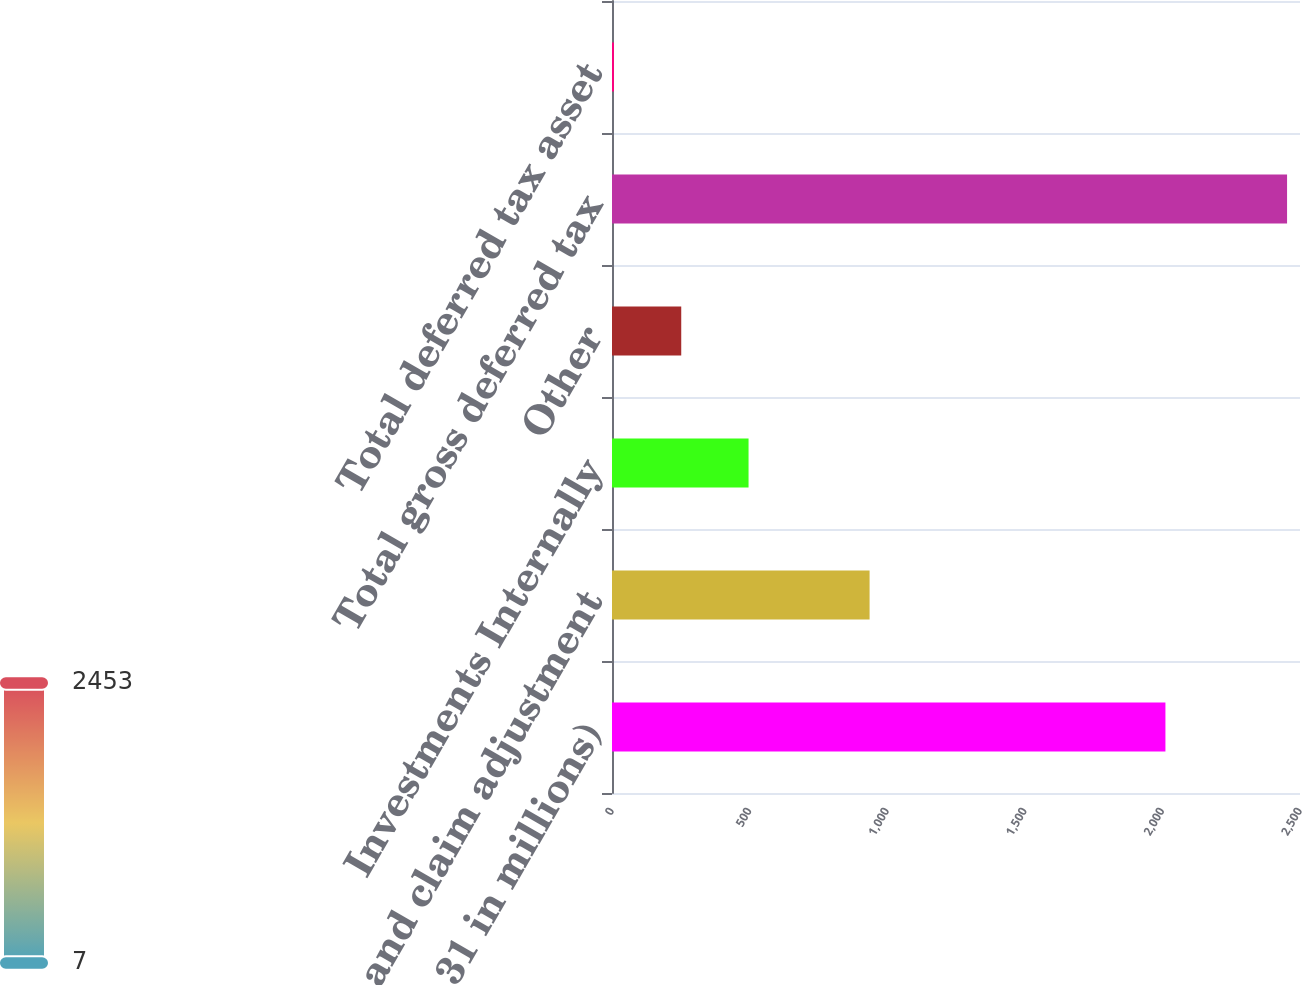Convert chart to OTSL. <chart><loc_0><loc_0><loc_500><loc_500><bar_chart><fcel>(at December 31 in millions)<fcel>Claims and claim adjustment<fcel>Investments Internally<fcel>Other<fcel>Total gross deferred tax<fcel>Total deferred tax asset<nl><fcel>2011<fcel>936<fcel>496.2<fcel>251.6<fcel>2453<fcel>7<nl></chart> 